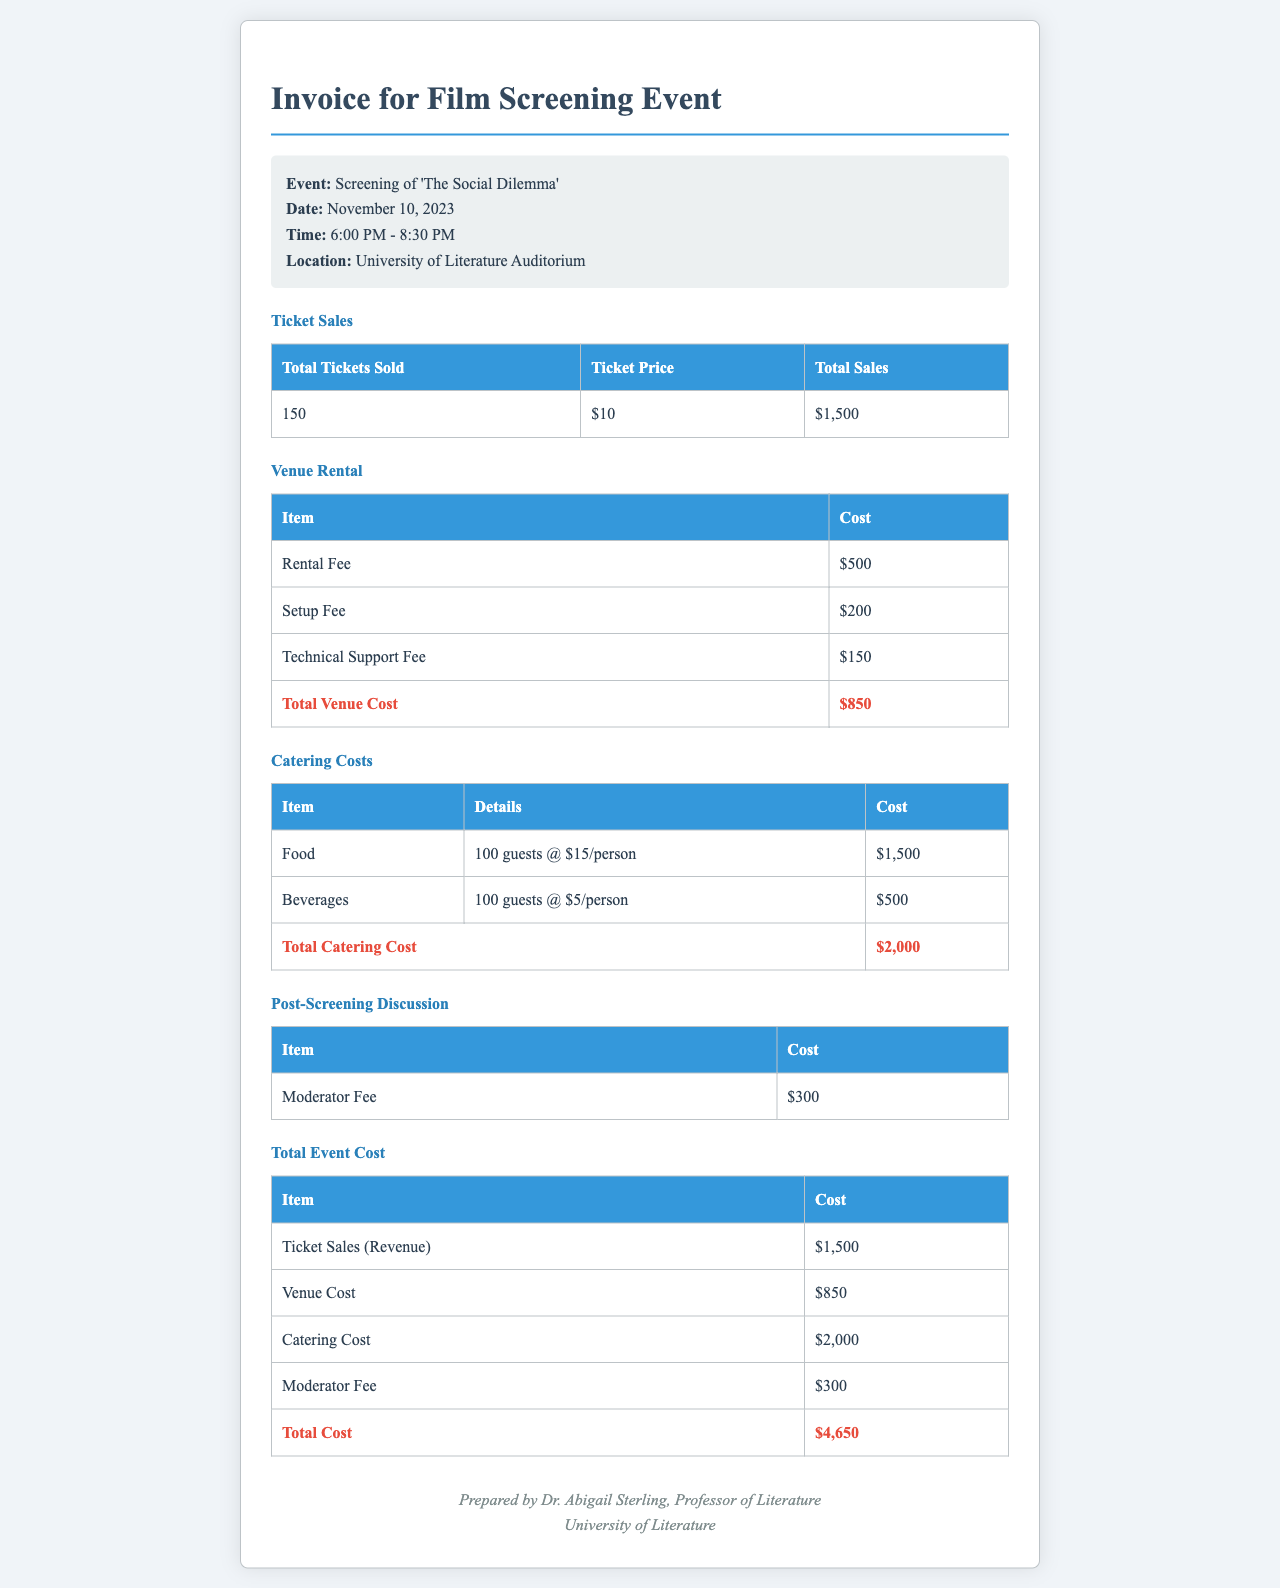What is the event name? The event name is specified in the document under the event details section.
Answer: Screening of 'The Social Dilemma' What was the total ticket sales? The total ticket sales are calculated from the number of tickets sold multiplied by the ticket price.
Answer: $1,500 How many guests were catered for? The catering cost details mention that 100 guests were accounted for food and beverages.
Answer: 100 guests What is the total venue cost? The total venue cost is the sum of the rental fee, setup fee, and technical support fee.
Answer: $850 What is the moderator fee? The fee for the moderator is listed in the post-screening discussion section.
Answer: $300 What is the total catering cost? The total catering cost is provided in the catering costs section, summing up food and beverages costs.
Answer: $2,000 What is the total cost of the event? The total cost includes all expenses from ticket sales, venue, catering, and the moderator fee.
Answer: $4,650 What is the location of the event? The location is provided in the event details section.
Answer: University of Literature Auditorium On what date is the screening scheduled? The date is mentioned in the event details section of the document.
Answer: November 10, 2023 